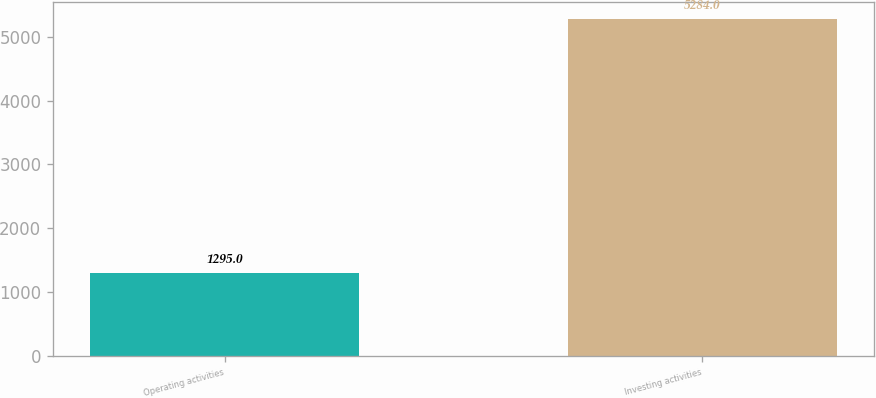<chart> <loc_0><loc_0><loc_500><loc_500><bar_chart><fcel>Operating activities<fcel>Investing activities<nl><fcel>1295<fcel>5284<nl></chart> 